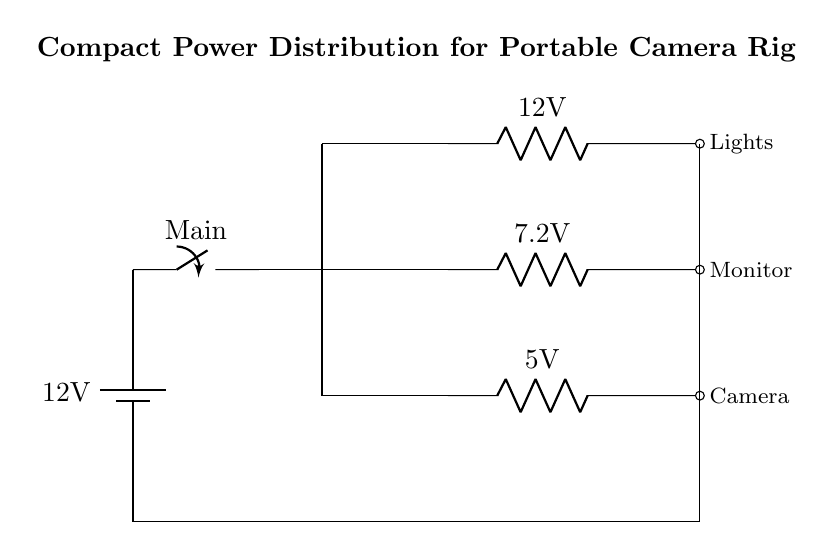What is the main voltage of the power source? The main voltage is indicated as 12 volts from the battery in the circuit diagram.
Answer: 12 volts What type of switch is used in this circuit? The diagram identifies the component as a "Main" switch, which is a simple on/off switch for controlling the power supply to the circuit.
Answer: Main switch How many output channels are provided in this circuit? There are three output channels indicated in the circuit connected to the distribution block, each supplying power to different components.
Answer: Three What is the voltage supplied to the camera? The voltage supplied to the camera is shown to be 5 volts from the corresponding resistor in the circuit.
Answer: 5 volts What component is used to reduce voltage to the monitor? The voltage to the monitor is reduced by a resistor marked as 7.2 volts, indicating the voltage supplied to that specific output channel.
Answer: Resistor Which component requires the highest voltage in this circuit? The lights require the highest voltage, indicated as 12 volts in the circuit diagram, which matches the battery voltage.
Answer: Lights 